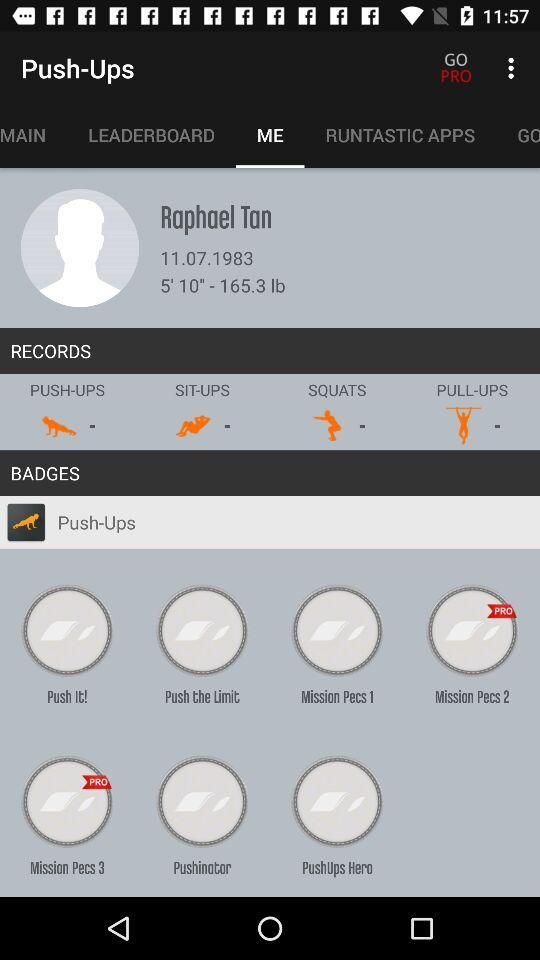What is the height and weight? The height is 5 feet 10 inches and the weight is 165.3 pounds. 